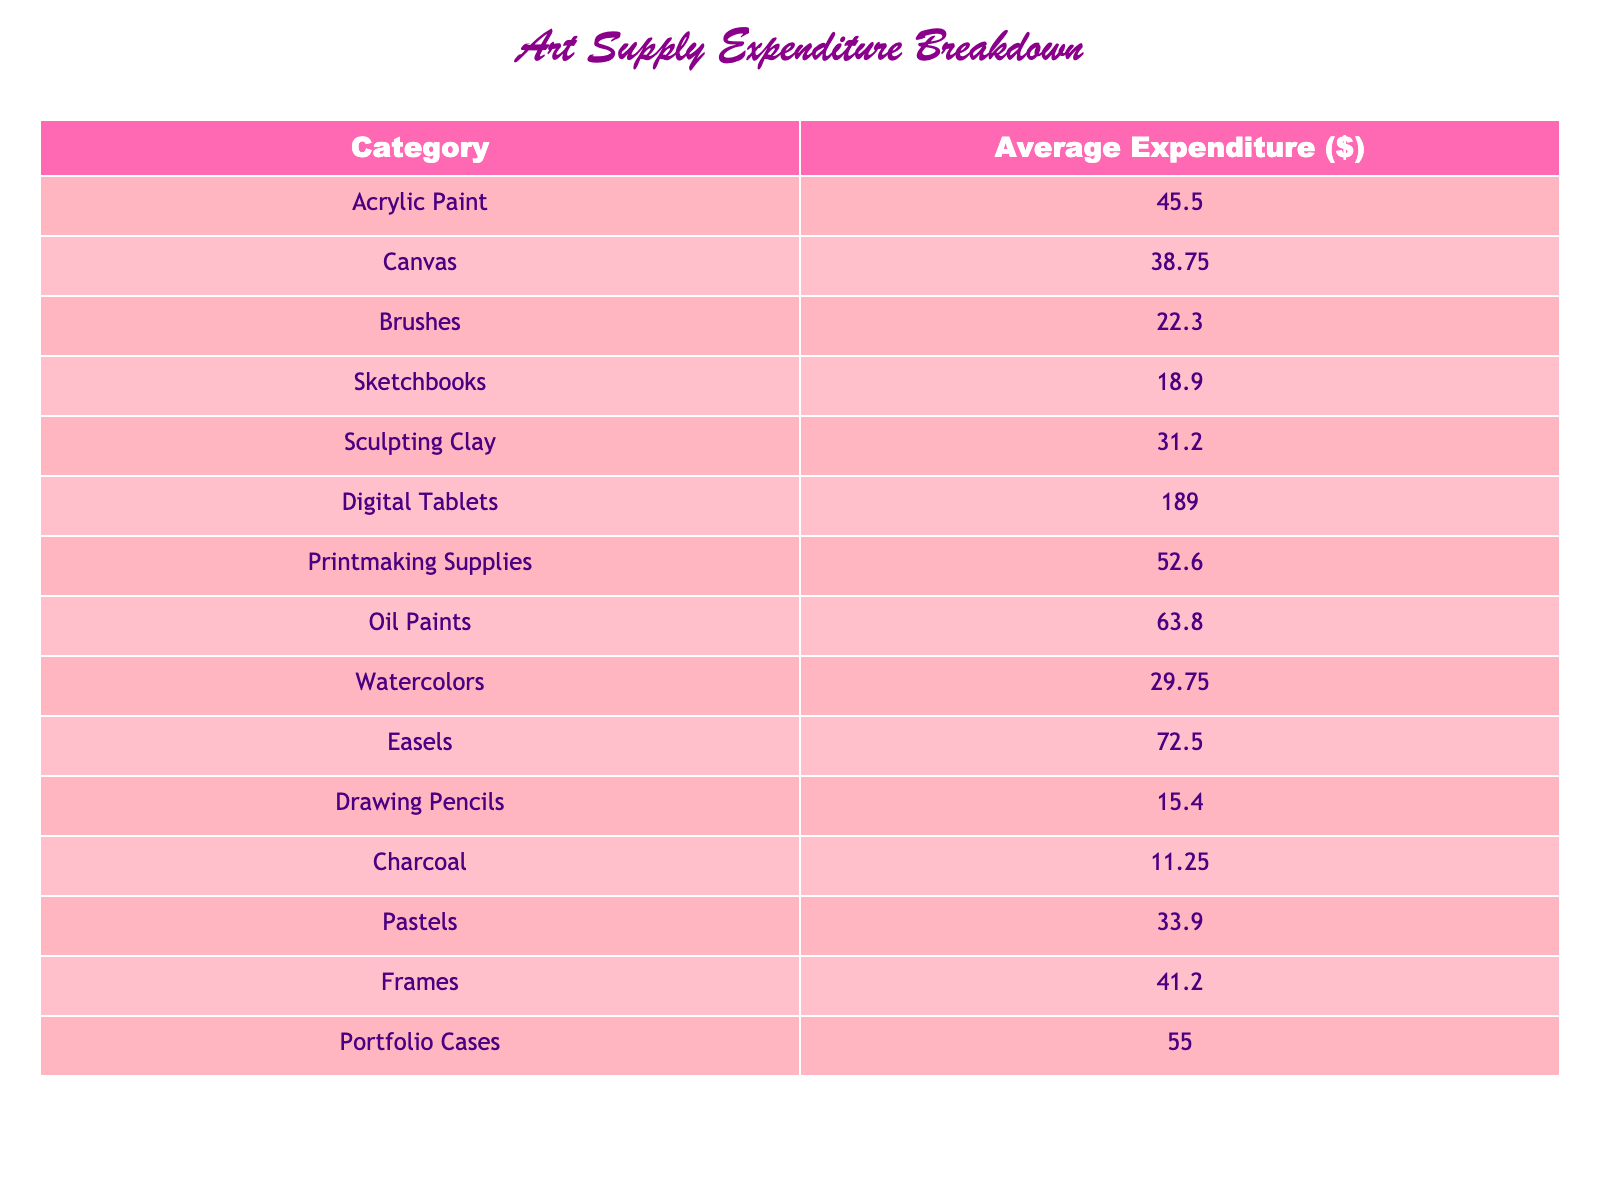What is the average expenditure on Digital Tablets? The table shows that the average expenditure on Digital Tablets is listed directly as $189.00.
Answer: $189.00 Which category has the highest average expenditure? The table indicates that the highest average expenditure is for Digital Tablets, which is $189.00, comparing to other categories.
Answer: Digital Tablets What is the combined average expenditure of Brushes and Drawing Pencils? The average expenditure for Brushes is $22.30, and for Drawing Pencils, it is $15.40. Adding these two amounts gives $22.30 + $15.40 = $37.70.
Answer: $37.70 How much more is spent on Oil Paints compared to Charcoal? The average for Oil Paints is $63.80 and for Charcoal, it is $11.25. The difference is $63.80 - $11.25 = $52.55.
Answer: $52.55 Is the average expenditure on Watercolors less than that on Sketchbooks? The average for Watercolors is $29.75 and for Sketchbooks, it is $18.90. Since $29.75 is greater than $18.90, the statement is false.
Answer: No What is the total average expenditure for all painting supplies (Acrylic Paint, Oil Paints, and Watercolors)? Adding the average expenditures gives $45.50 (Acrylic) + $63.80 (Oil) + $29.75 (Watercolors) = $139.05.
Answer: $139.05 Which categories have an average expenditure greater than $50? By checking the table, the average expenditures greater than $50 are Digital Tablets ($189.00), Oil Paints ($63.80), Printmaking Supplies ($52.60), and Easels ($72.50).
Answer: Digital Tablets, Oil Paints, Printmaking Supplies, Easels What is the median average expenditure of all the categories listed? There are 15 categories listed. To find the median, we first arrange the average expenditures in ascending order, and since we have an odd number, the median is the middle value (8th value), which is $41.20 (Frames).
Answer: $41.20 How much is spent on Canvas compared to the average of all categories? The average for Canvas is $38.75. The average expenditure of all categories can be calculated as the sum of all expenditures divided by the total number of categories. The total is $45.50 + $38.75 + ... + $55.00 = $788.85, and there are 15 categories, resulting in an average of $52.59. $38.75 is less than $52.59.
Answer: Less than Is the average expenditure on Pastels higher than that on Brushes? The average expenditure for Pastels is $33.90, and for Brushes it is $22.30. Since $33.90 is greater than $22.30, the statement is true.
Answer: Yes 